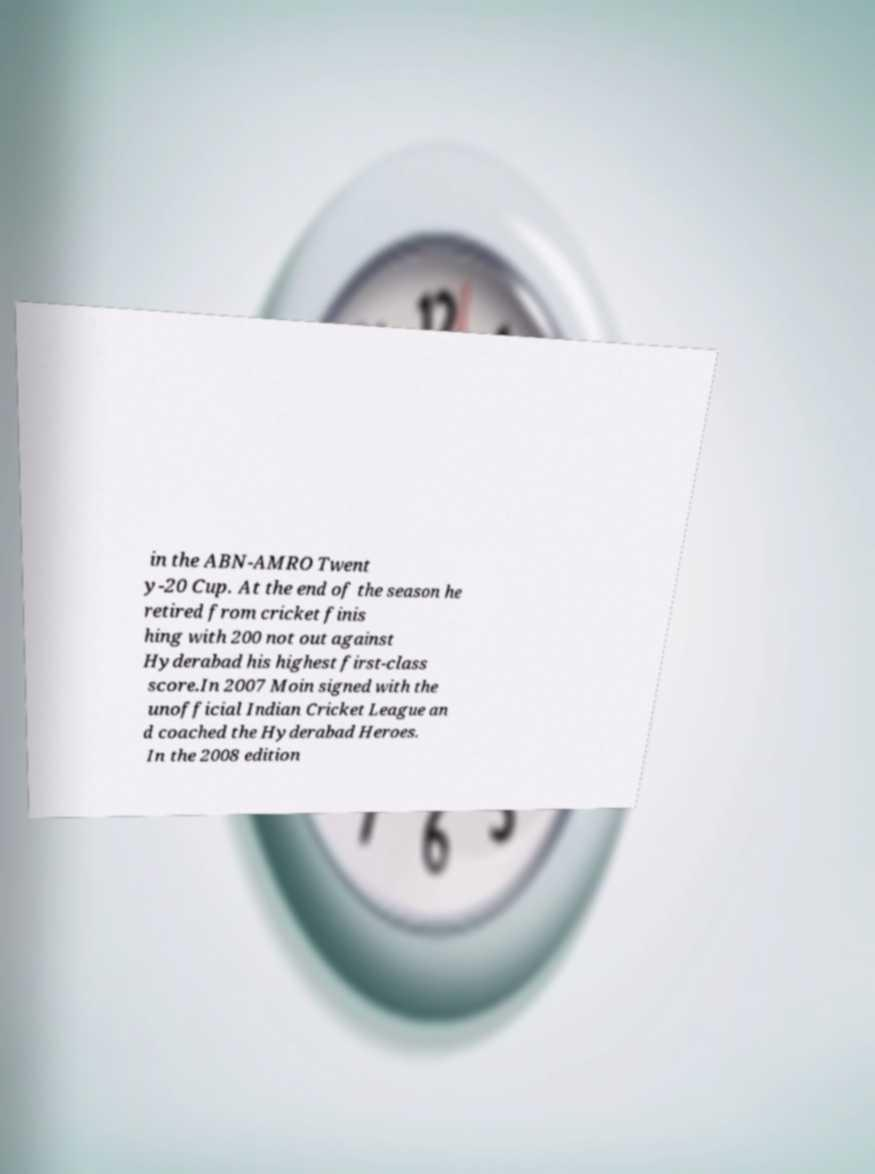Could you assist in decoding the text presented in this image and type it out clearly? in the ABN-AMRO Twent y-20 Cup. At the end of the season he retired from cricket finis hing with 200 not out against Hyderabad his highest first-class score.In 2007 Moin signed with the unofficial Indian Cricket League an d coached the Hyderabad Heroes. In the 2008 edition 